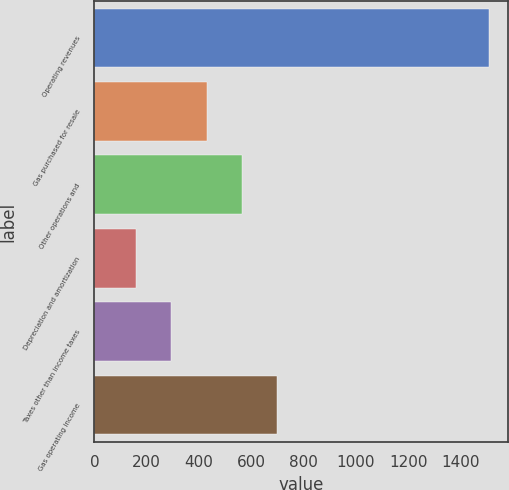Convert chart to OTSL. <chart><loc_0><loc_0><loc_500><loc_500><bar_chart><fcel>Operating revenues<fcel>Gas purchased for resale<fcel>Other operations and<fcel>Depreciation and amortization<fcel>Taxes other than income taxes<fcel>Gas operating income<nl><fcel>1508<fcel>428.8<fcel>563.7<fcel>159<fcel>293.9<fcel>698.6<nl></chart> 